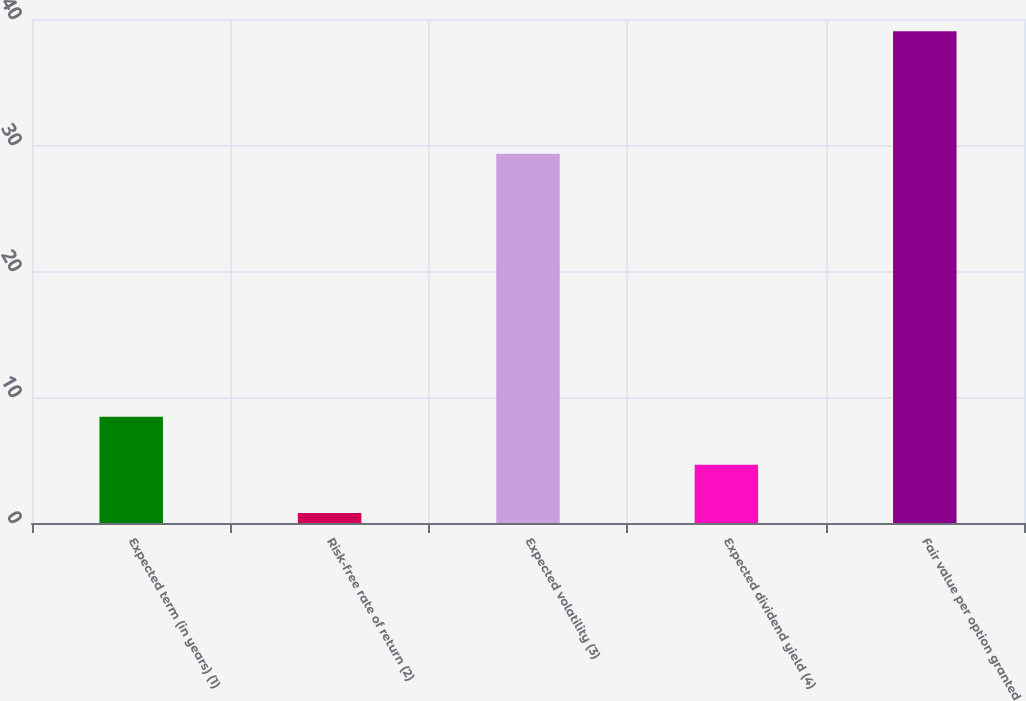Convert chart to OTSL. <chart><loc_0><loc_0><loc_500><loc_500><bar_chart><fcel>Expected term (in years) (1)<fcel>Risk-free rate of return (2)<fcel>Expected volatility (3)<fcel>Expected dividend yield (4)<fcel>Fair value per option granted<nl><fcel>8.44<fcel>0.8<fcel>29.3<fcel>4.62<fcel>39.03<nl></chart> 